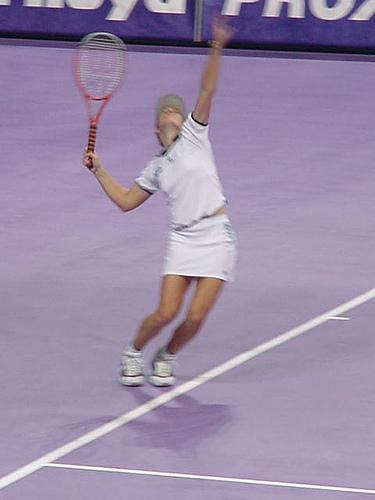Where is the woman playing?
Give a very brief answer. Tennis court. What color is the courtyard?
Write a very short answer. Purple. What sport is this?
Write a very short answer. Tennis. 